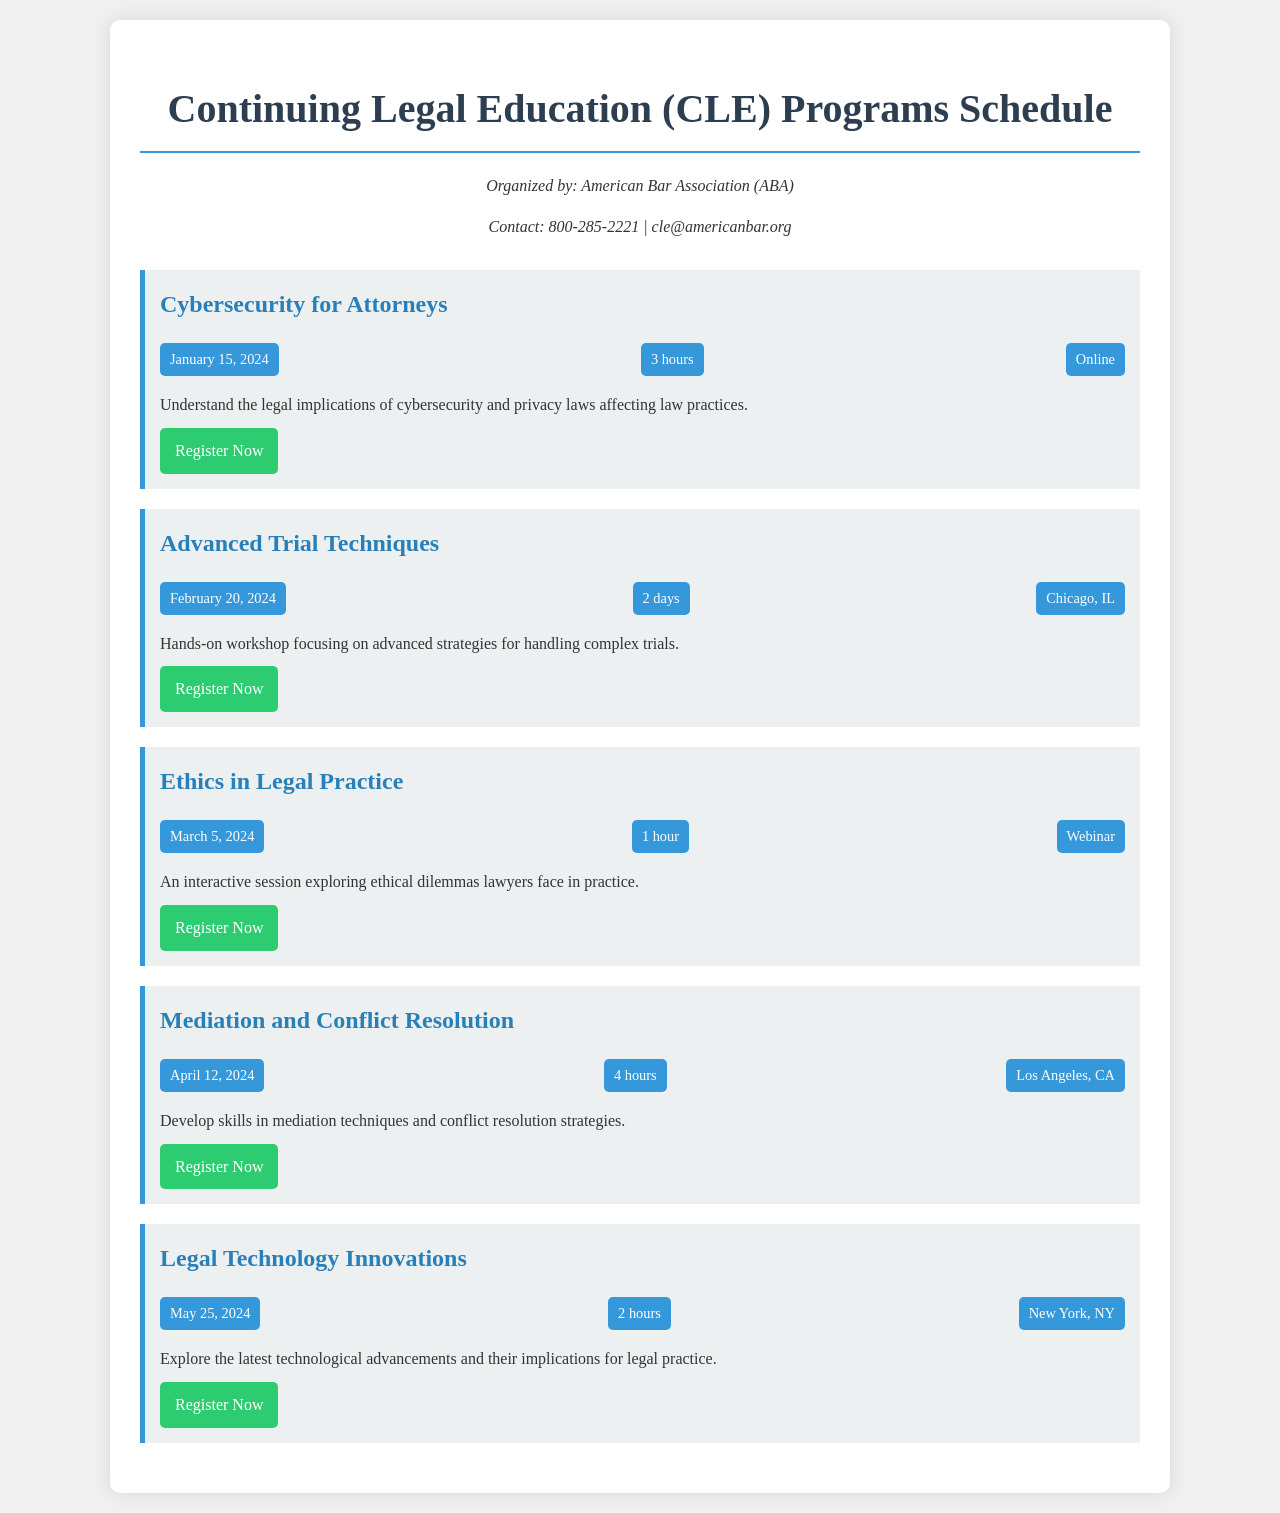What is the duration of the "Cybersecurity for Attorneys" course? The duration of the course is specified in the course details, which states it is for 3 hours.
Answer: 3 hours When is the "Advanced Trial Techniques" course scheduled? The date for the course is provided in the course details, which lists it as February 20, 2024.
Answer: February 20, 2024 How many hours is the "Mediation and Conflict Resolution" course? The course details indicate that it lasts for 4 hours.
Answer: 4 hours Where is the "Legal Technology Innovations" course taking place? The location is mentioned in the course details, which states it will be held in New York, NY.
Answer: New York, NY What type of course is "Ethics in Legal Practice"? The course type is specified as a webinar in the course details.
Answer: Webinar How many courses are offered in this schedule? The total number of courses listed in the document is five.
Answer: 5 What is the primary focus of the "Mediation and Conflict Resolution" course? The description states it is focused on developing skills in mediation techniques and conflict resolution strategies.
Answer: Mediation techniques and conflict resolution Which organization is hosting these CLE programs? The hosting organization is explicitly mentioned in the document's contact information as the American Bar Association (ABA).
Answer: American Bar Association (ABA) What is the contact number for queries regarding the CLE programs? The contact number is listed in the document, indicating 800-285-2221 for inquiries.
Answer: 800-285-2221 